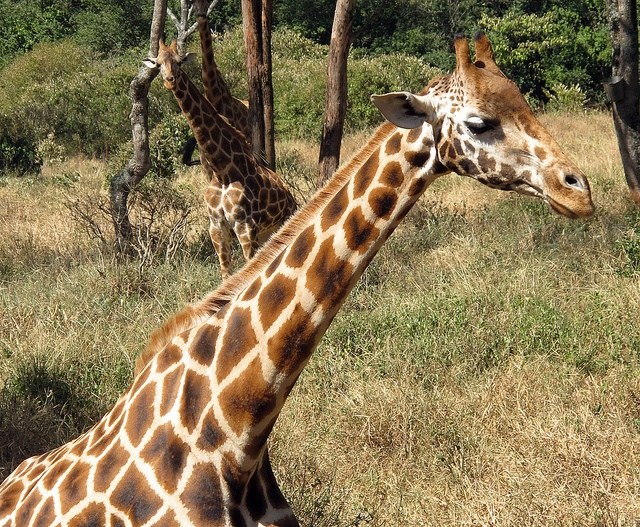Describe the objects in this image and their specific colors. I can see giraffe in black, ivory, brown, tan, and gray tones, giraffe in black, maroon, and gray tones, and giraffe in darkgreen, black, and gray tones in this image. 